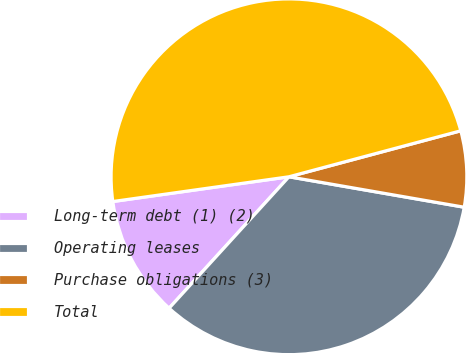Convert chart. <chart><loc_0><loc_0><loc_500><loc_500><pie_chart><fcel>Long-term debt (1) (2)<fcel>Operating leases<fcel>Purchase obligations (3)<fcel>Total<nl><fcel>11.01%<fcel>34.03%<fcel>6.9%<fcel>48.06%<nl></chart> 